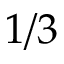<formula> <loc_0><loc_0><loc_500><loc_500>1 / 3</formula> 